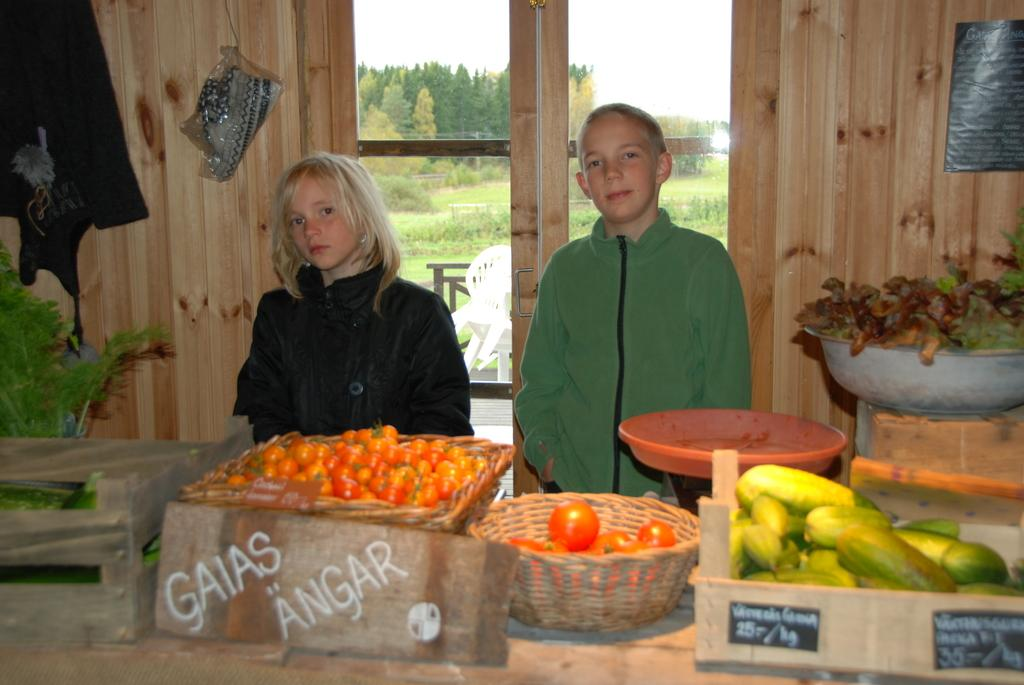What is the main piece of furniture in the image? There is a table in the image. What is on the table? There are vegetables in a basket on the table. What can be seen in the background of the image? There is a window in the image, and trees are visible through the window. How is the window positioned in the image? The window is between walls. What type of juice is being squeezed from the vegetables in the image? There is no juice being squeezed from the vegetables in the image; they are simply in a basket on the table. 